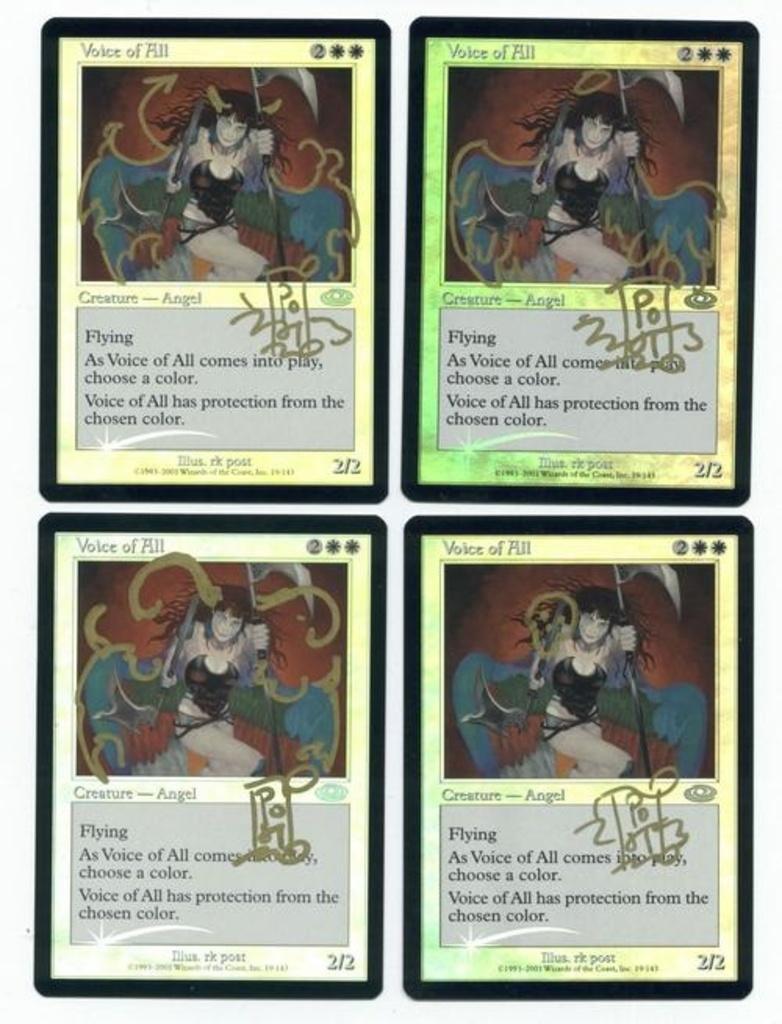In one or two sentences, can you explain what this image depicts? In this picture we can see collage image the collage of a cards. 